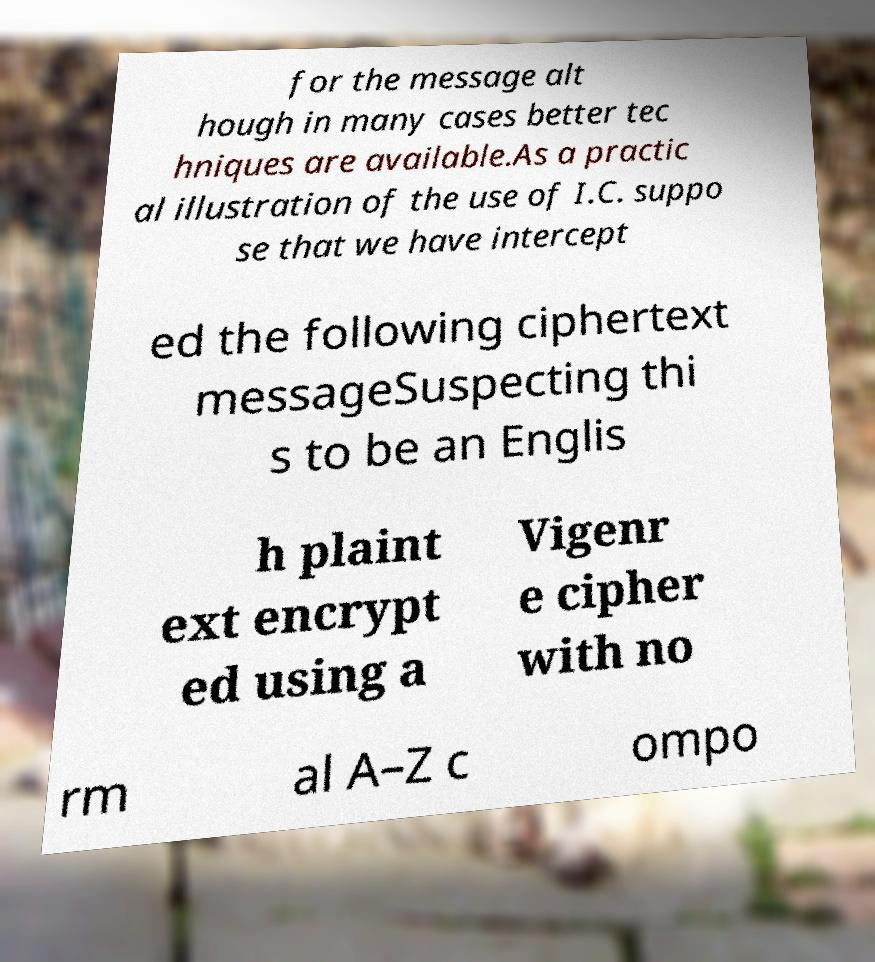There's text embedded in this image that I need extracted. Can you transcribe it verbatim? for the message alt hough in many cases better tec hniques are available.As a practic al illustration of the use of I.C. suppo se that we have intercept ed the following ciphertext messageSuspecting thi s to be an Englis h plaint ext encrypt ed using a Vigenr e cipher with no rm al A–Z c ompo 